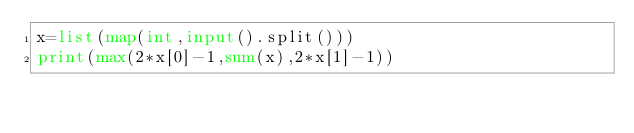Convert code to text. <code><loc_0><loc_0><loc_500><loc_500><_Python_>x=list(map(int,input().split()))
print(max(2*x[0]-1,sum(x),2*x[1]-1))
</code> 